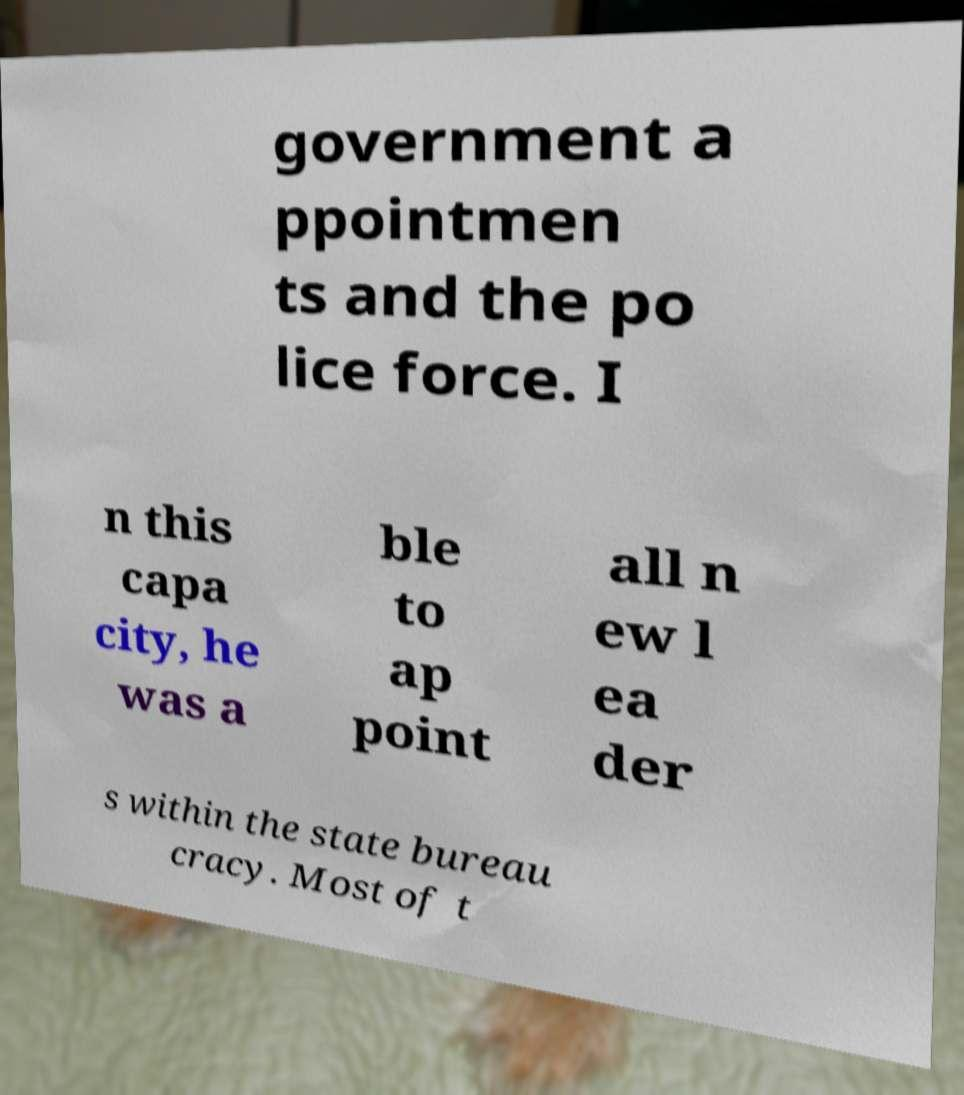I need the written content from this picture converted into text. Can you do that? government a ppointmen ts and the po lice force. I n this capa city, he was a ble to ap point all n ew l ea der s within the state bureau cracy. Most of t 